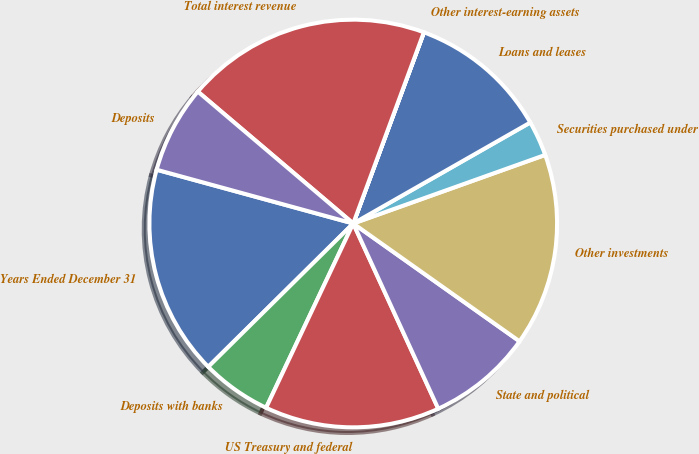<chart> <loc_0><loc_0><loc_500><loc_500><pie_chart><fcel>Years Ended December 31<fcel>Deposits with banks<fcel>US Treasury and federal<fcel>State and political<fcel>Other investments<fcel>Securities purchased under<fcel>Loans and leases<fcel>Other interest-earning assets<fcel>Total interest revenue<fcel>Deposits<nl><fcel>16.66%<fcel>5.56%<fcel>13.88%<fcel>8.34%<fcel>15.27%<fcel>2.79%<fcel>11.11%<fcel>0.01%<fcel>19.43%<fcel>6.95%<nl></chart> 